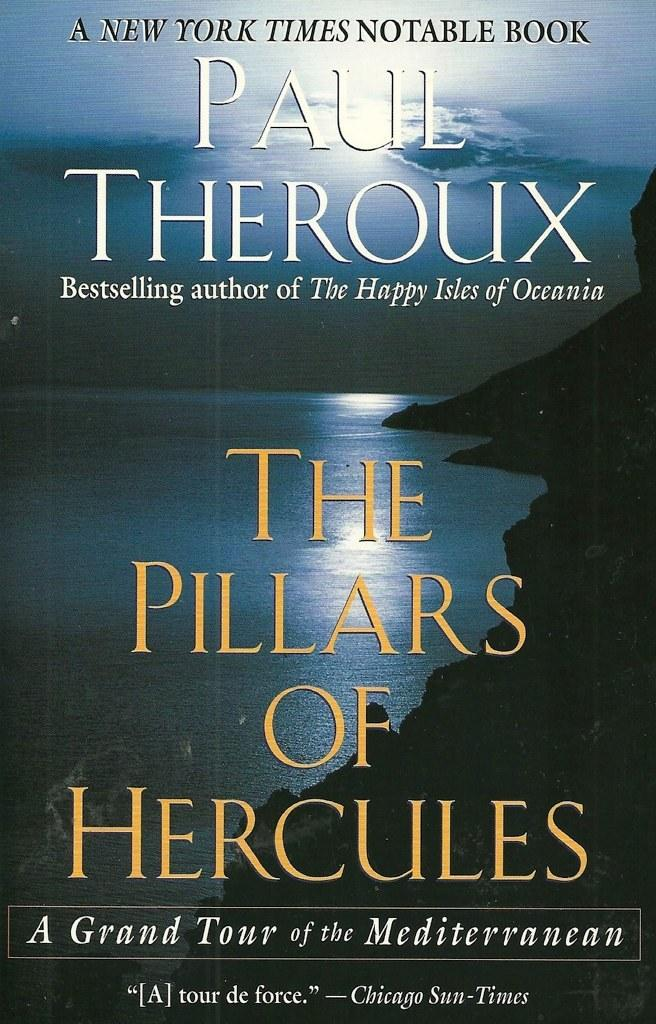Provide a one-sentence caption for the provided image. a book that is by paul theroux called the pillars of hercules. 